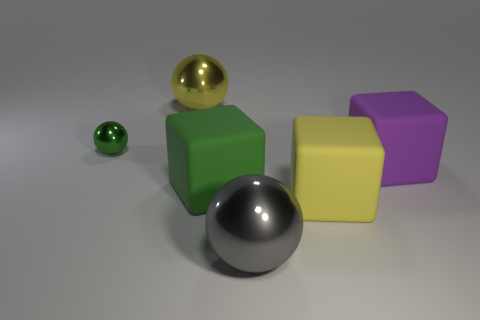Is the tiny green thing made of the same material as the cube to the right of the big yellow block?
Offer a terse response. No. What is the big yellow object in front of the purple rubber thing made of?
Provide a succinct answer. Rubber. What is the color of the large metal ball that is behind the gray thing?
Make the answer very short. Yellow. Is there a gray thing that has the same size as the green metal thing?
Provide a short and direct response. No. There is a green cube that is the same size as the gray metal sphere; what is its material?
Provide a succinct answer. Rubber. How many things are big cubes that are to the right of the large gray sphere or big matte blocks on the left side of the gray metallic sphere?
Your answer should be compact. 3. Is there another large gray thing of the same shape as the big gray object?
Make the answer very short. No. How many matte objects are either green things or tiny cyan objects?
Ensure brevity in your answer.  1. What shape is the small green thing?
Provide a succinct answer. Sphere. How many yellow spheres have the same material as the big purple cube?
Keep it short and to the point. 0. 